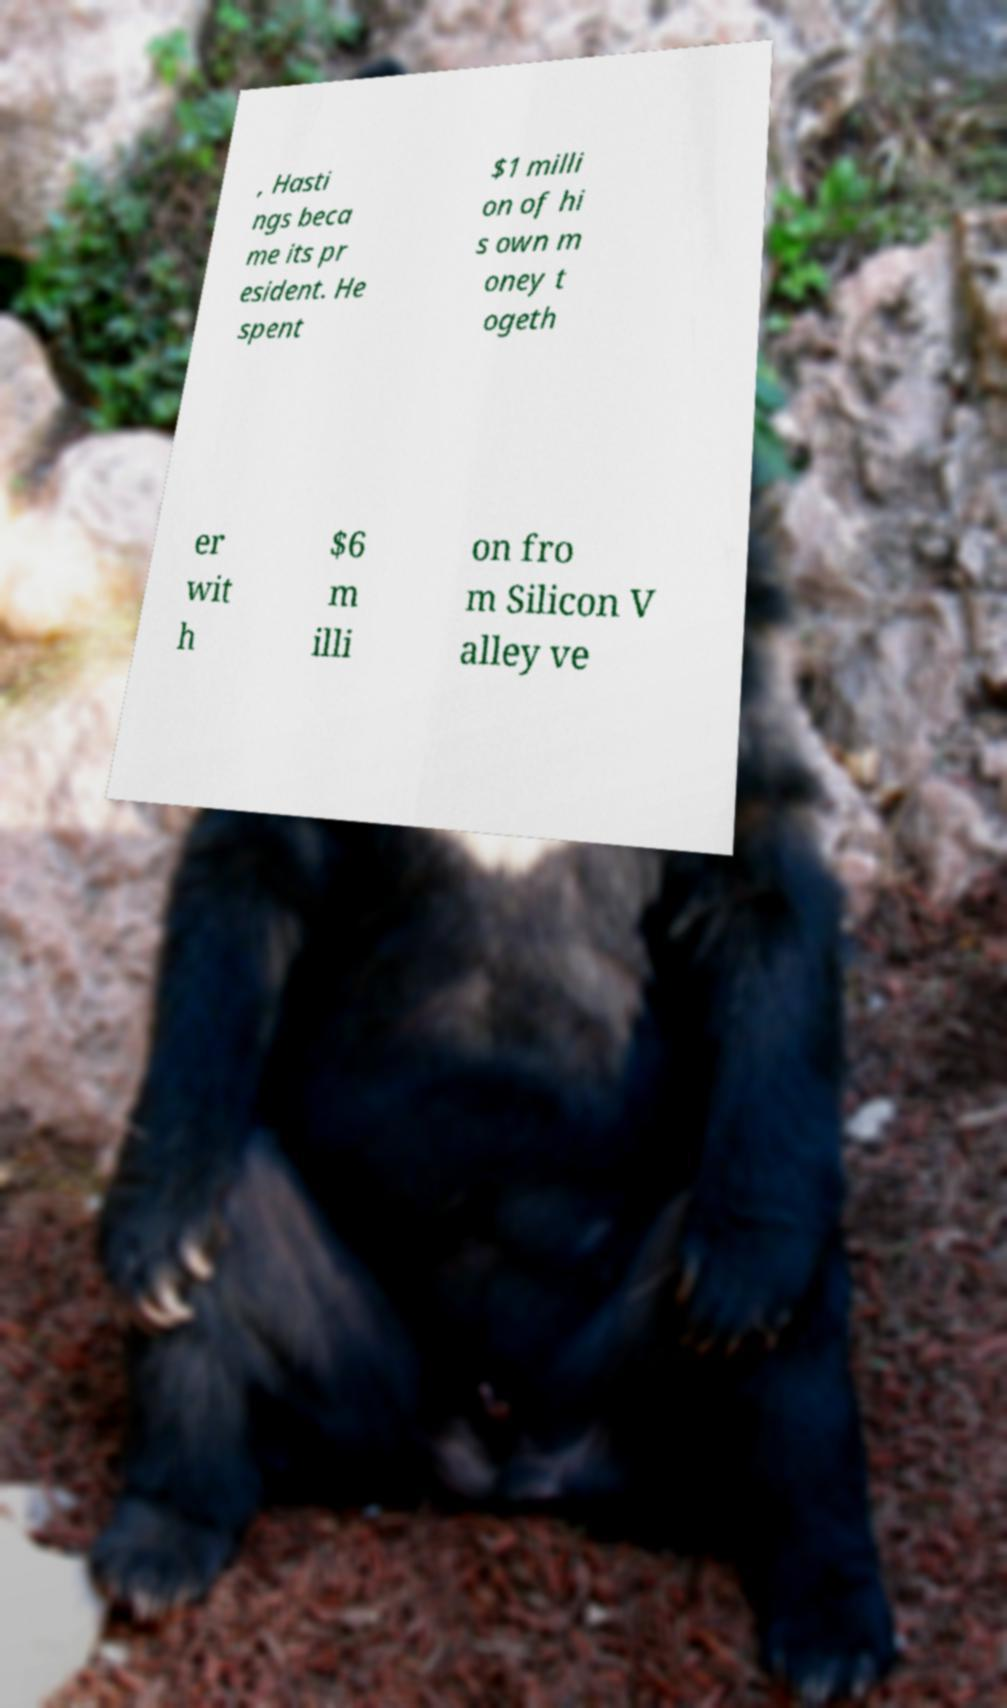For documentation purposes, I need the text within this image transcribed. Could you provide that? , Hasti ngs beca me its pr esident. He spent $1 milli on of hi s own m oney t ogeth er wit h $6 m illi on fro m Silicon V alley ve 